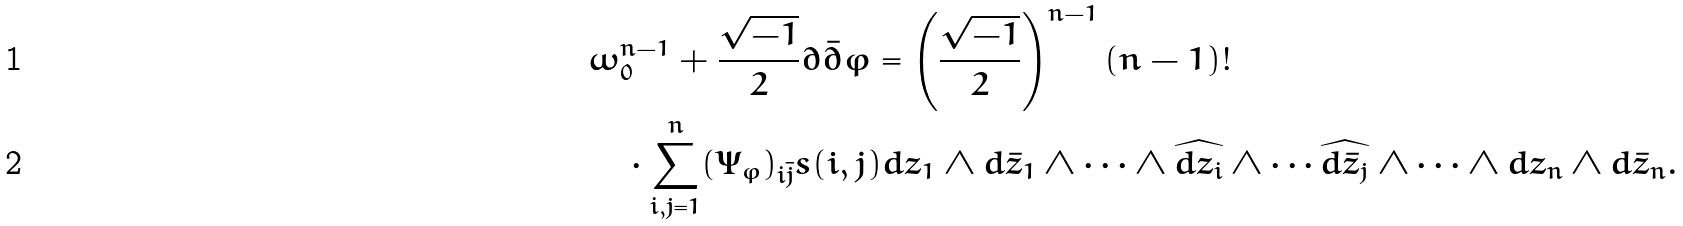Convert formula to latex. <formula><loc_0><loc_0><loc_500><loc_500>& \omega _ { 0 } ^ { n - 1 } + \frac { \sqrt { - 1 } } { 2 } \partial \bar { \partial } \varphi = \left ( \frac { \sqrt { - 1 } } { 2 } \right ) ^ { n - 1 } ( n - 1 ) ! \\ & \quad \cdot \sum _ { i , j = 1 } ^ { n } ( \Psi _ { \varphi } ) _ { i \bar { j } } s ( i , j ) d z _ { 1 } \wedge d \bar { z } _ { 1 } \wedge \cdots \wedge \widehat { d z _ { i } } \wedge \cdots \widehat { d \bar { z } _ { j } } \wedge \cdots \wedge d z _ { n } \wedge d \bar { z } _ { n } .</formula> 